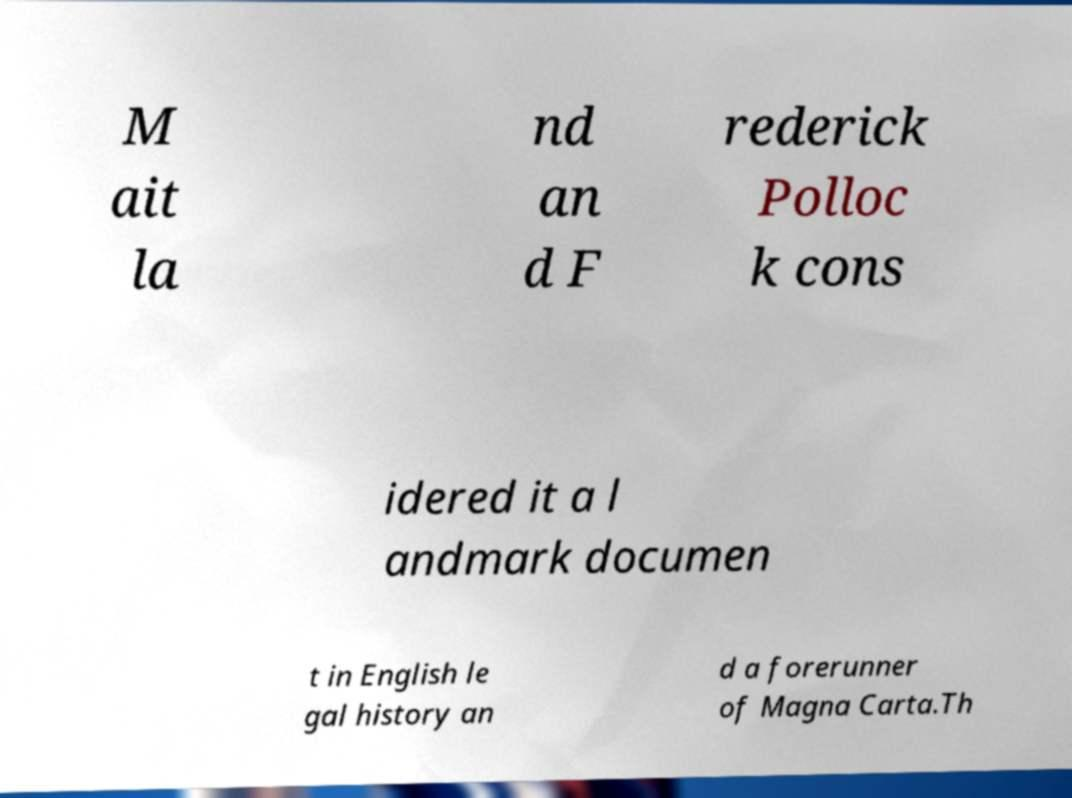Could you assist in decoding the text presented in this image and type it out clearly? M ait la nd an d F rederick Polloc k cons idered it a l andmark documen t in English le gal history an d a forerunner of Magna Carta.Th 